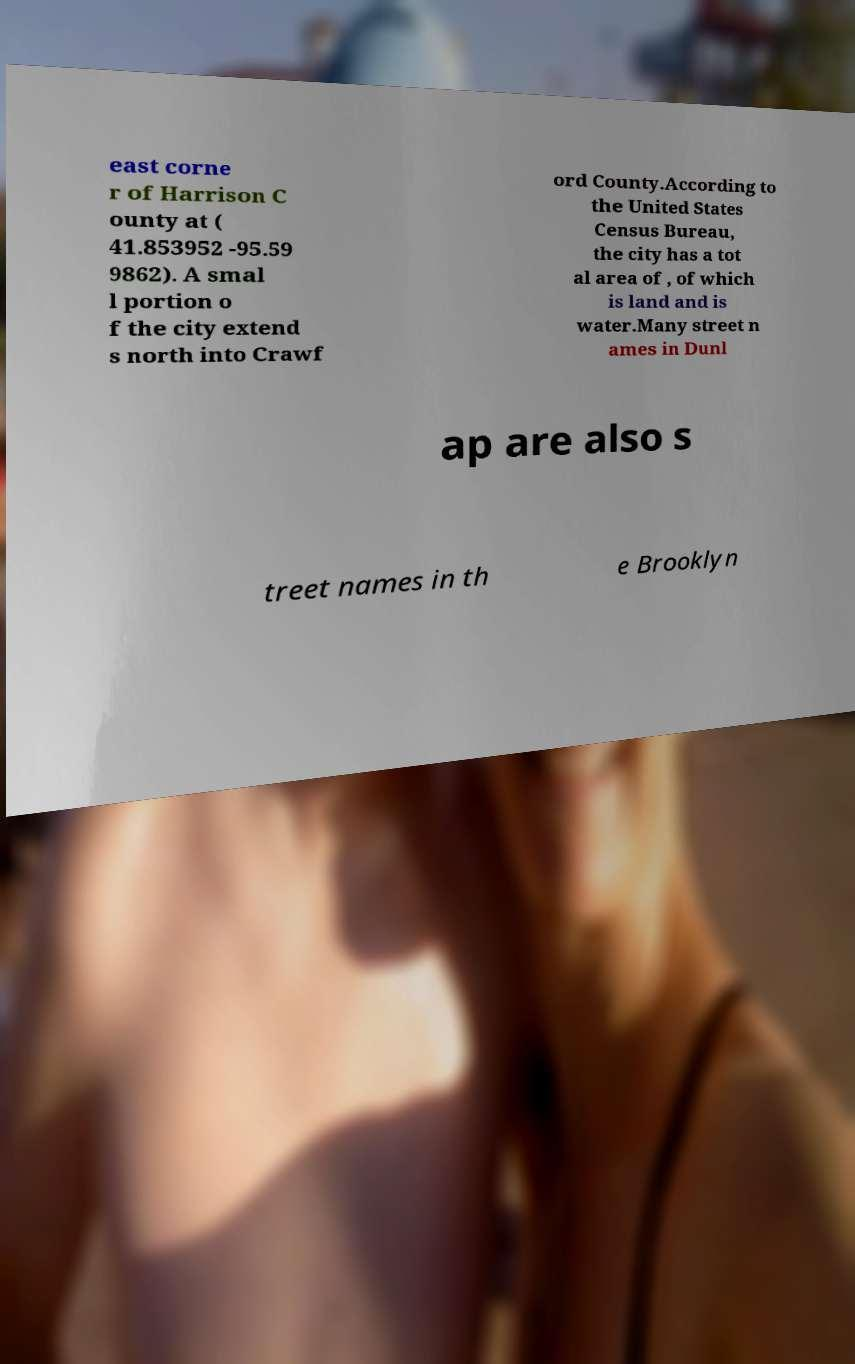What messages or text are displayed in this image? I need them in a readable, typed format. east corne r of Harrison C ounty at ( 41.853952 -95.59 9862). A smal l portion o f the city extend s north into Crawf ord County.According to the United States Census Bureau, the city has a tot al area of , of which is land and is water.Many street n ames in Dunl ap are also s treet names in th e Brooklyn 